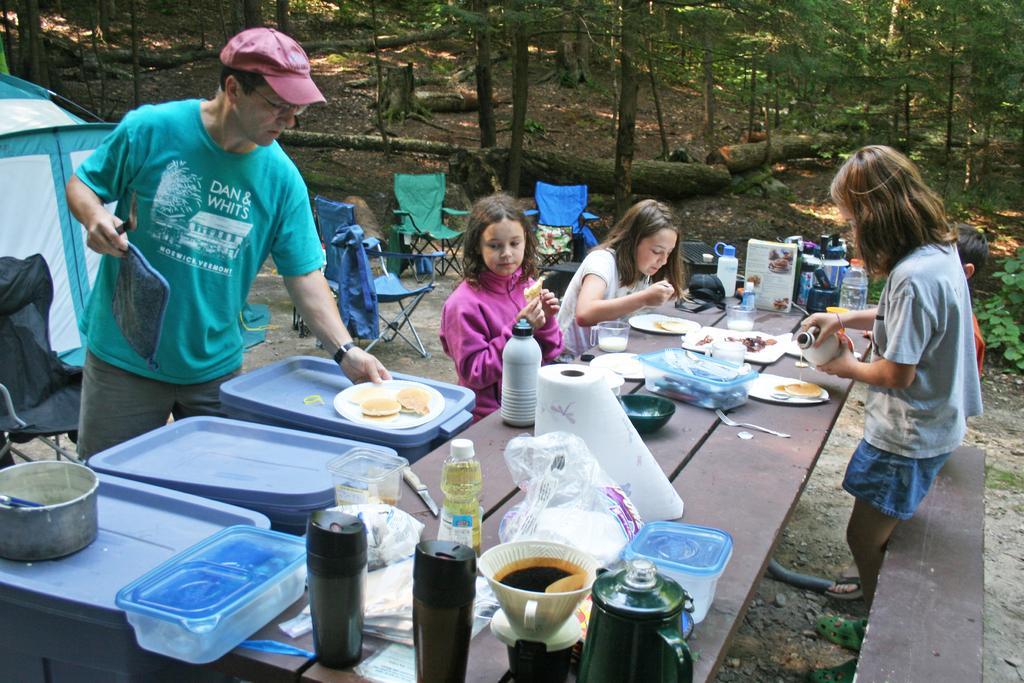How would you summarize this image in a sentence or two? In this image there are two persons sitting and eating some food as we can see in the middle of this image. There is one kid standing on the right side of this image is holding a bottle and there is one kid is back side to this kid. There is a table in the bottom of this image and there are cups,bottles and some other objects are kept on to this table. There is one person standing on the left side of this image is holding an object. There are some trays kept on the right side of this image. There are some chairs in the middle of this image and there are some trees in the background. There is a tent on the left side of this image. There is a table on the bottom right corner of this image. 